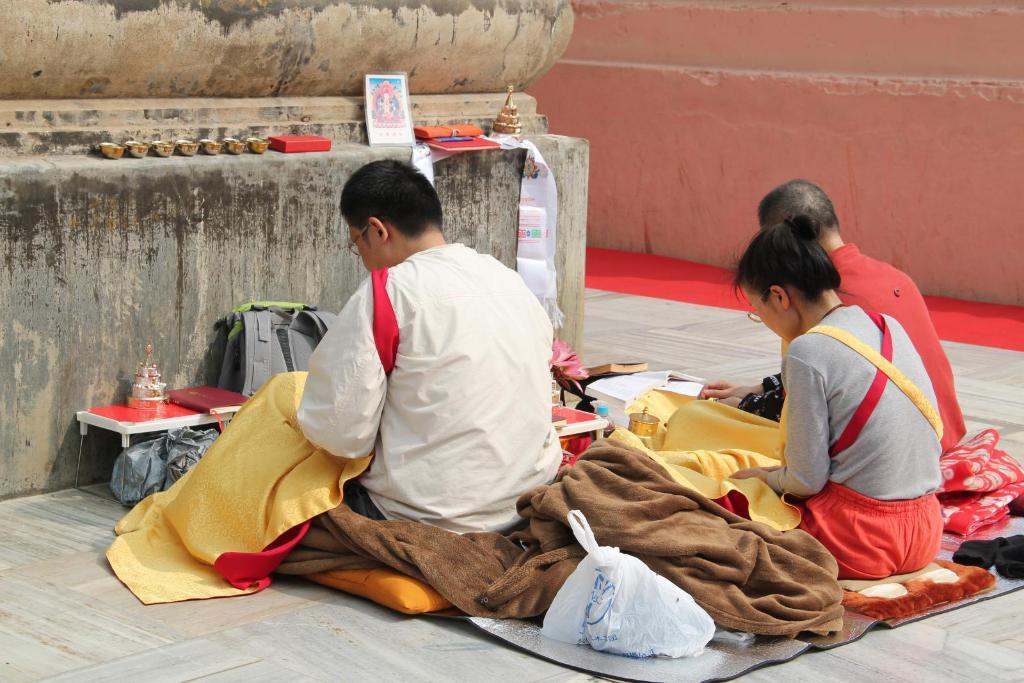How would you summarize this image in a sentence or two? In this image there are three people sitting on a mat, and also there are some blankets, plastic covers, bags, stool, books, flowers, bottles and some other objects and there is a photo frame and some objects. At the bottom there is floor, and in the background there is wall and carpet. 